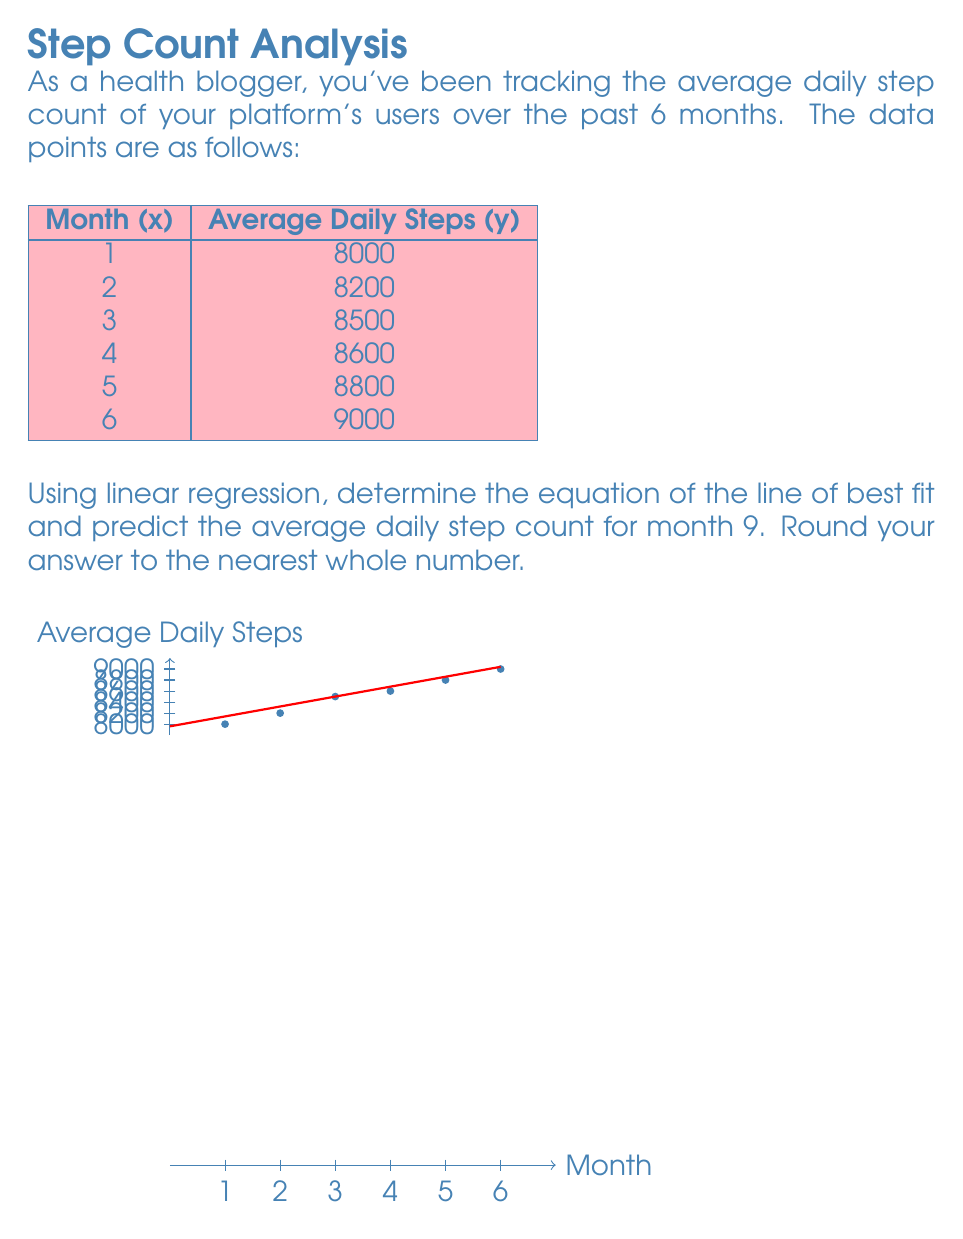What is the answer to this math problem? To solve this problem, we'll use the linear regression formula:

$$y = mx + b$$

Where $m$ is the slope and $b$ is the y-intercept.

Step 1: Calculate the means of x and y.
$$\bar{x} = \frac{1+2+3+4+5+6}{6} = 3.5$$
$$\bar{y} = \frac{8000+8200+8500+8600+8800+9000}{6} = 8516.67$$

Step 2: Calculate the slope (m).
$$m = \frac{\sum(x_i - \bar{x})(y_i - \bar{y})}{\sum(x_i - \bar{x})^2}$$

$$m = \frac{(-2.5)(-516.67) + (-1.5)(-316.67) + (-0.5)(16.67) + (0.5)(83.33) + (1.5)(283.33) + (2.5)(483.33)}{(-2.5)^2 + (-1.5)^2 + (-0.5)^2 + (0.5)^2 + (1.5)^2 + (2.5)^2}$$

$$m = \frac{3250}{17.5} = 185.71$$

Step 3: Calculate the y-intercept (b).
$$b = \bar{y} - m\bar{x} = 8516.67 - 185.71(3.5) = 7866.67$$

Step 4: Form the equation of the line.
$$y = 185.71x + 7866.67$$

Step 5: Predict the average daily step count for month 9.
$$y = 185.71(9) + 7866.67 = 9538.06$$

Rounding to the nearest whole number: 9538
Answer: 9538 steps 